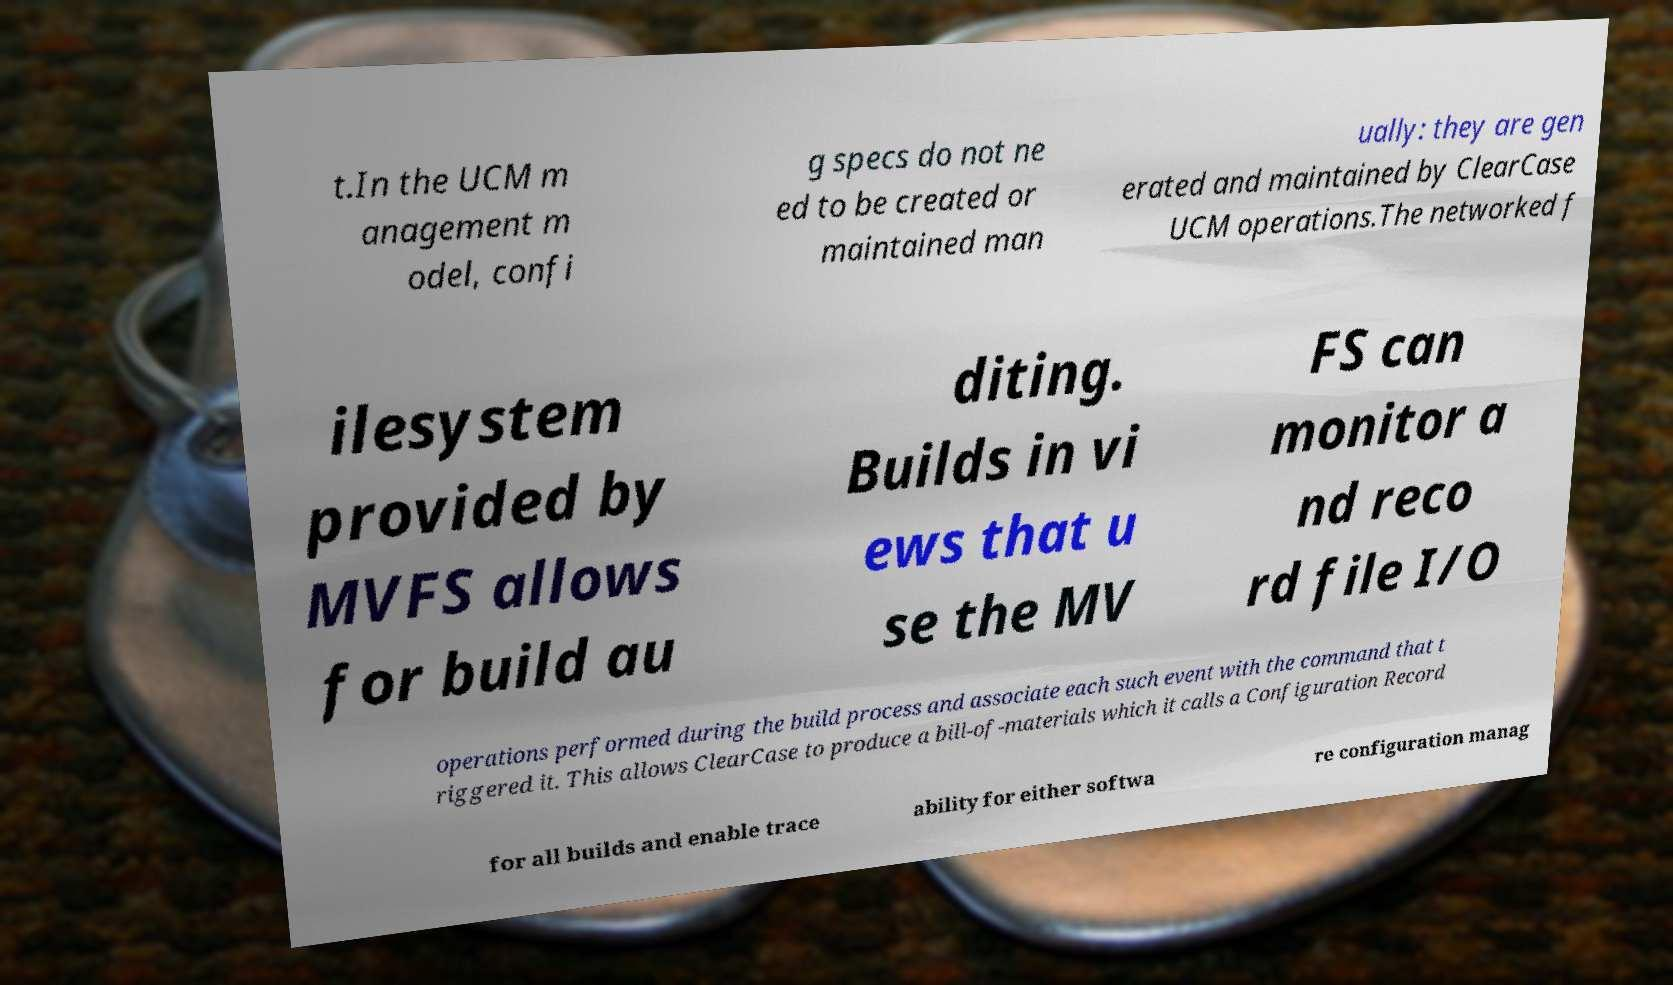For documentation purposes, I need the text within this image transcribed. Could you provide that? t.In the UCM m anagement m odel, confi g specs do not ne ed to be created or maintained man ually: they are gen erated and maintained by ClearCase UCM operations.The networked f ilesystem provided by MVFS allows for build au diting. Builds in vi ews that u se the MV FS can monitor a nd reco rd file I/O operations performed during the build process and associate each such event with the command that t riggered it. This allows ClearCase to produce a bill-of-materials which it calls a Configuration Record for all builds and enable trace ability for either softwa re configuration manag 